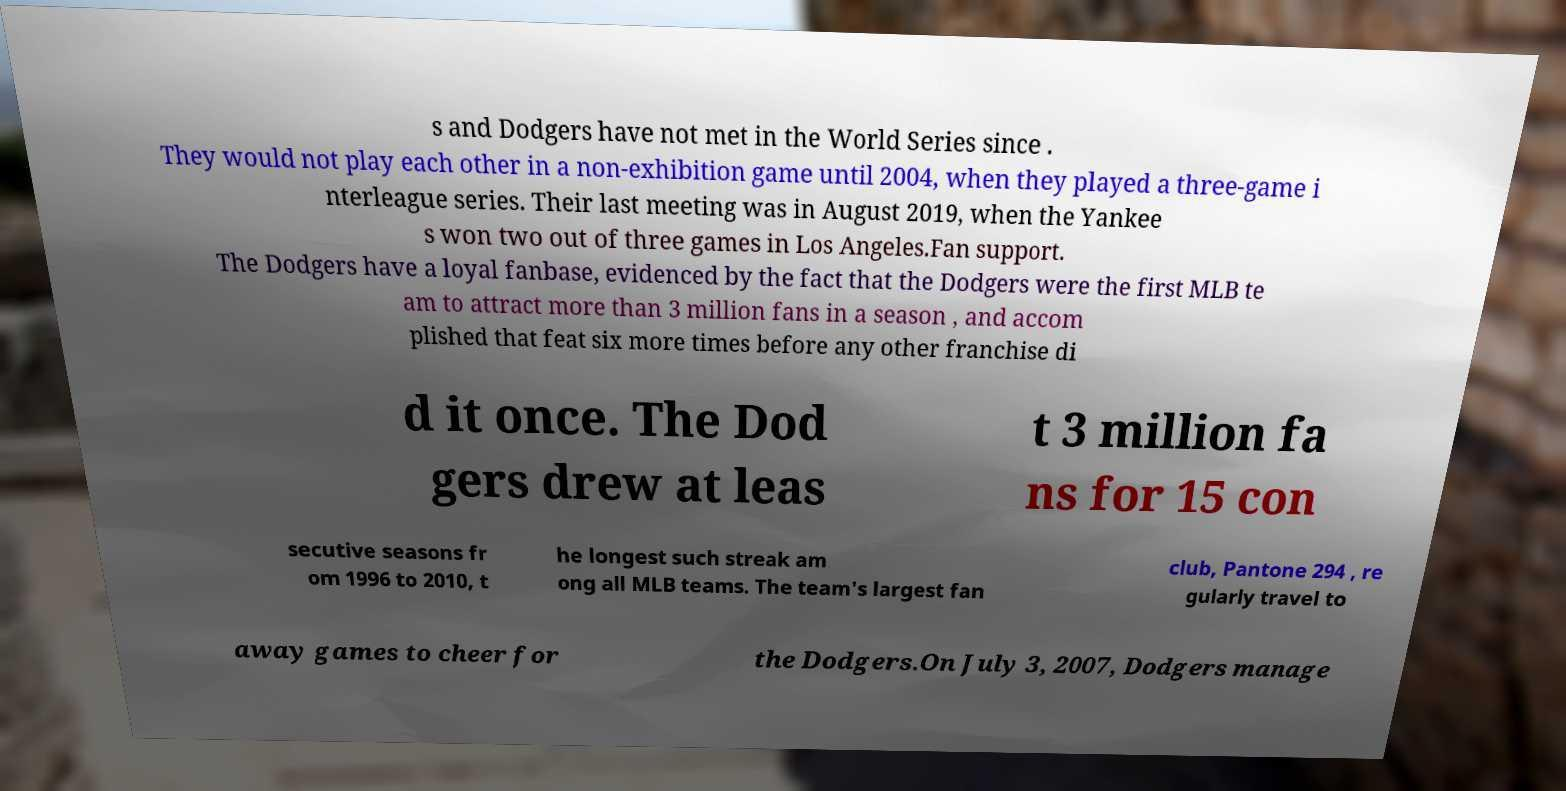Please read and relay the text visible in this image. What does it say? s and Dodgers have not met in the World Series since . They would not play each other in a non-exhibition game until 2004, when they played a three-game i nterleague series. Their last meeting was in August 2019, when the Yankee s won two out of three games in Los Angeles.Fan support. The Dodgers have a loyal fanbase, evidenced by the fact that the Dodgers were the first MLB te am to attract more than 3 million fans in a season , and accom plished that feat six more times before any other franchise di d it once. The Dod gers drew at leas t 3 million fa ns for 15 con secutive seasons fr om 1996 to 2010, t he longest such streak am ong all MLB teams. The team's largest fan club, Pantone 294 , re gularly travel to away games to cheer for the Dodgers.On July 3, 2007, Dodgers manage 